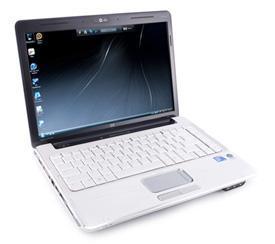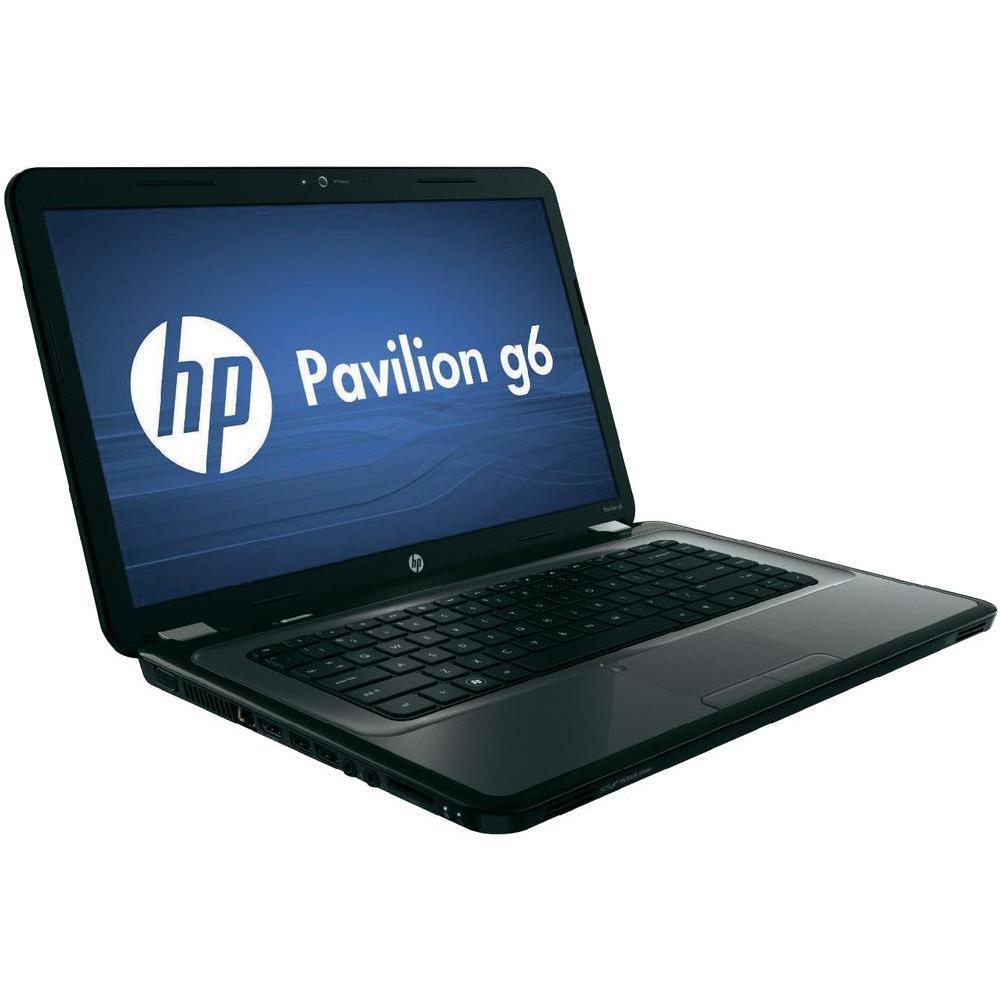The first image is the image on the left, the second image is the image on the right. Considering the images on both sides, is "All laptops are angled with the open screen facing rightward, and one laptop features a blue screen with a white circle logo on it." valid? Answer yes or no. Yes. The first image is the image on the left, the second image is the image on the right. Evaluate the accuracy of this statement regarding the images: "there is a laptop with a screen showing a windows logo with light shining through the window". Is it true? Answer yes or no. No. 